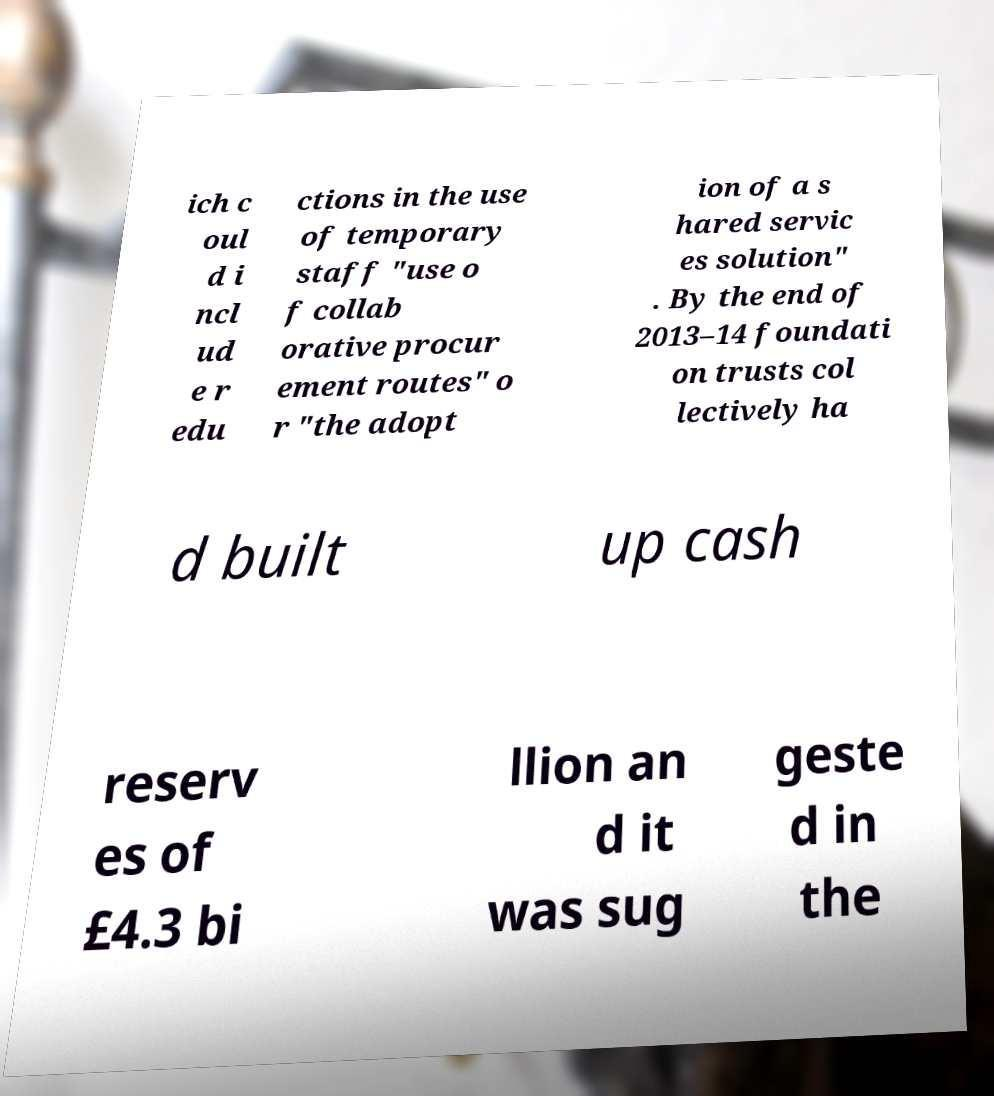Could you extract and type out the text from this image? ich c oul d i ncl ud e r edu ctions in the use of temporary staff "use o f collab orative procur ement routes" o r "the adopt ion of a s hared servic es solution" . By the end of 2013–14 foundati on trusts col lectively ha d built up cash reserv es of £4.3 bi llion an d it was sug geste d in the 